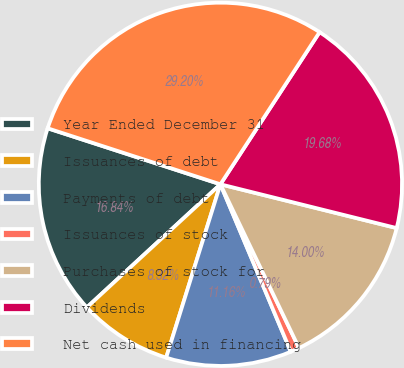<chart> <loc_0><loc_0><loc_500><loc_500><pie_chart><fcel>Year Ended December 31<fcel>Issuances of debt<fcel>Payments of debt<fcel>Issuances of stock<fcel>Purchases of stock for<fcel>Dividends<fcel>Net cash used in financing<nl><fcel>16.84%<fcel>8.32%<fcel>11.16%<fcel>0.79%<fcel>14.0%<fcel>19.68%<fcel>29.2%<nl></chart> 